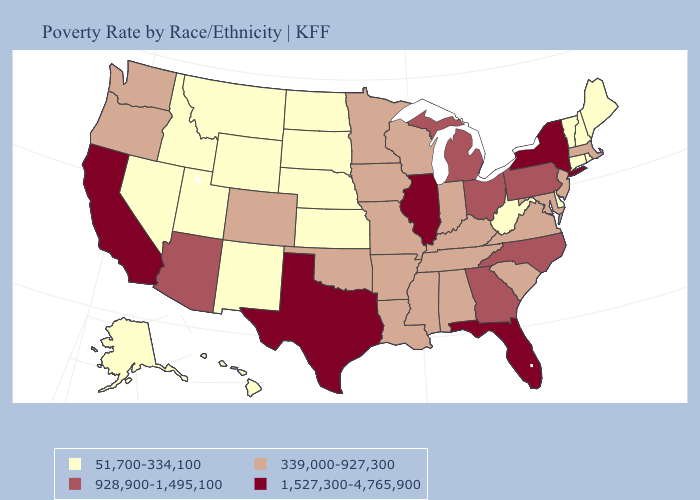Among the states that border Nevada , does Oregon have the lowest value?
Write a very short answer. No. Does Montana have the highest value in the USA?
Keep it brief. No. What is the highest value in the USA?
Answer briefly. 1,527,300-4,765,900. Which states have the lowest value in the USA?
Quick response, please. Alaska, Connecticut, Delaware, Hawaii, Idaho, Kansas, Maine, Montana, Nebraska, Nevada, New Hampshire, New Mexico, North Dakota, Rhode Island, South Dakota, Utah, Vermont, West Virginia, Wyoming. What is the lowest value in the West?
Be succinct. 51,700-334,100. Name the states that have a value in the range 51,700-334,100?
Answer briefly. Alaska, Connecticut, Delaware, Hawaii, Idaho, Kansas, Maine, Montana, Nebraska, Nevada, New Hampshire, New Mexico, North Dakota, Rhode Island, South Dakota, Utah, Vermont, West Virginia, Wyoming. Does Maine have the highest value in the Northeast?
Quick response, please. No. What is the value of South Dakota?
Keep it brief. 51,700-334,100. Among the states that border Iowa , does Wisconsin have the highest value?
Short answer required. No. Which states have the highest value in the USA?
Answer briefly. California, Florida, Illinois, New York, Texas. Name the states that have a value in the range 928,900-1,495,100?
Quick response, please. Arizona, Georgia, Michigan, North Carolina, Ohio, Pennsylvania. Does New Hampshire have the highest value in the Northeast?
Concise answer only. No. What is the lowest value in states that border Montana?
Answer briefly. 51,700-334,100. Name the states that have a value in the range 1,527,300-4,765,900?
Keep it brief. California, Florida, Illinois, New York, Texas. Name the states that have a value in the range 339,000-927,300?
Concise answer only. Alabama, Arkansas, Colorado, Indiana, Iowa, Kentucky, Louisiana, Maryland, Massachusetts, Minnesota, Mississippi, Missouri, New Jersey, Oklahoma, Oregon, South Carolina, Tennessee, Virginia, Washington, Wisconsin. 